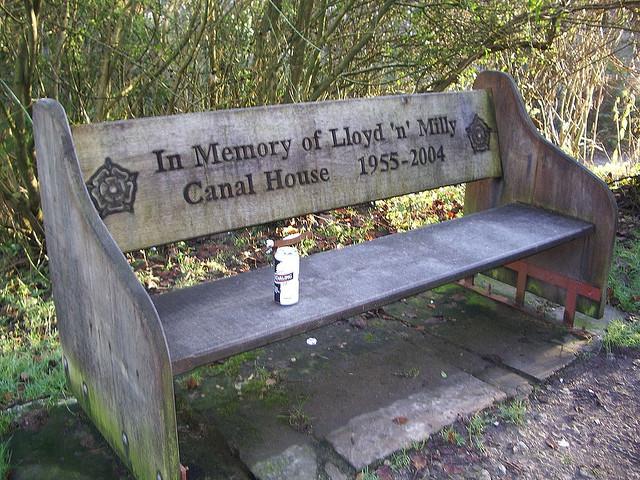What is the bench made out of?
Keep it brief. Wood. What are the years displayed?
Write a very short answer. 1955-2004. Who was this bench dedicated to?
Answer briefly. Lloyd 'n' milly. 